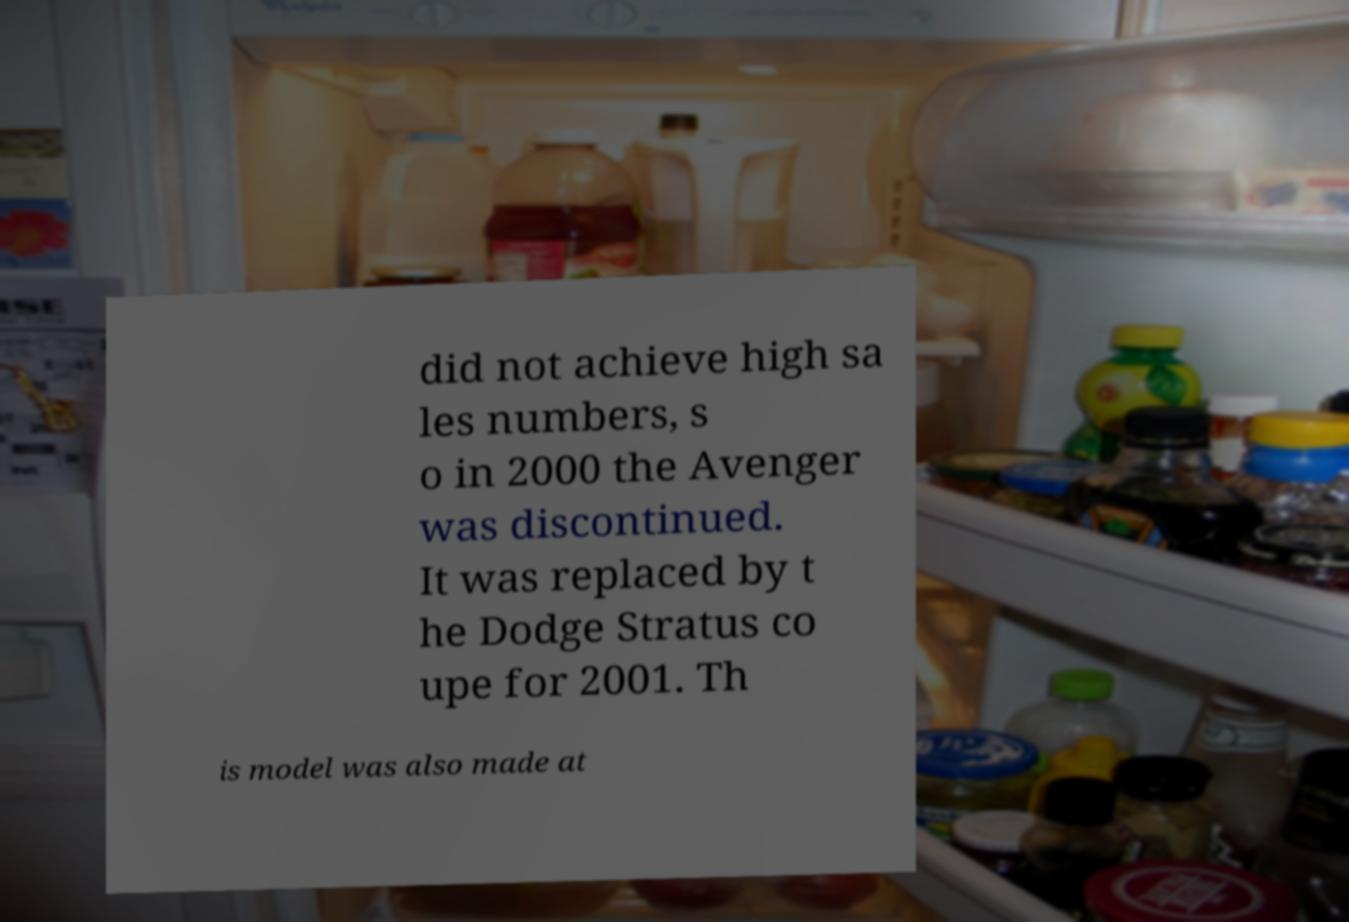Can you accurately transcribe the text from the provided image for me? did not achieve high sa les numbers, s o in 2000 the Avenger was discontinued. It was replaced by t he Dodge Stratus co upe for 2001. Th is model was also made at 